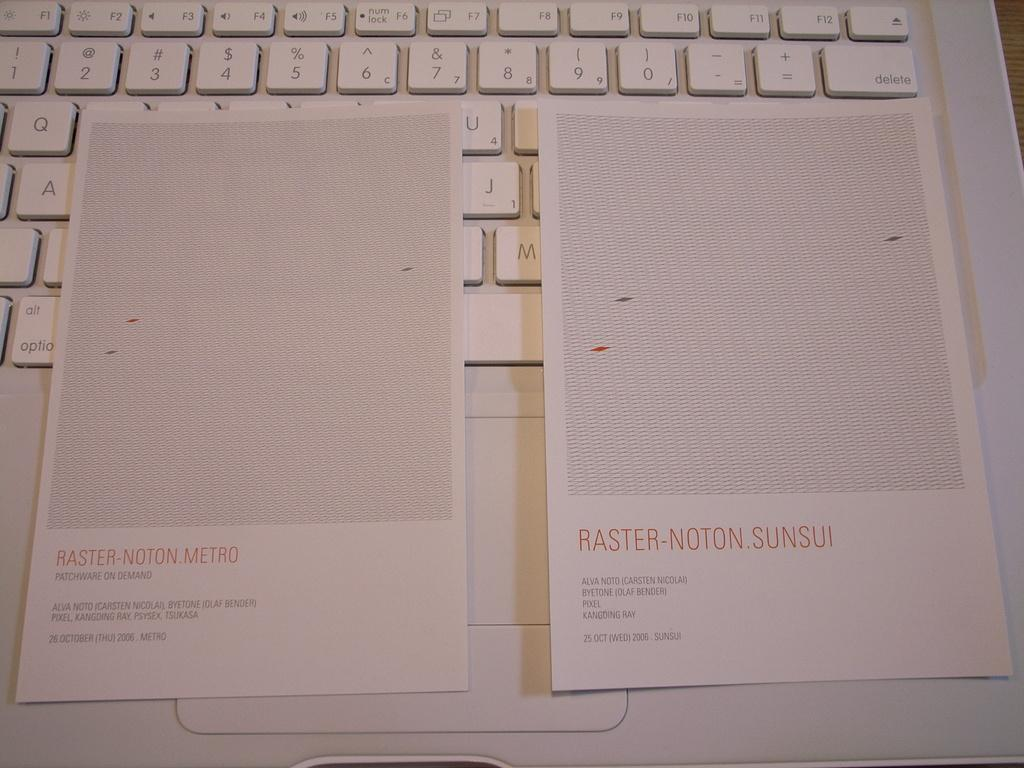<image>
Offer a succinct explanation of the picture presented. twp pieces of paper on a keyboard saying Raster Notion Metro and Raster Noton Sunsui. 